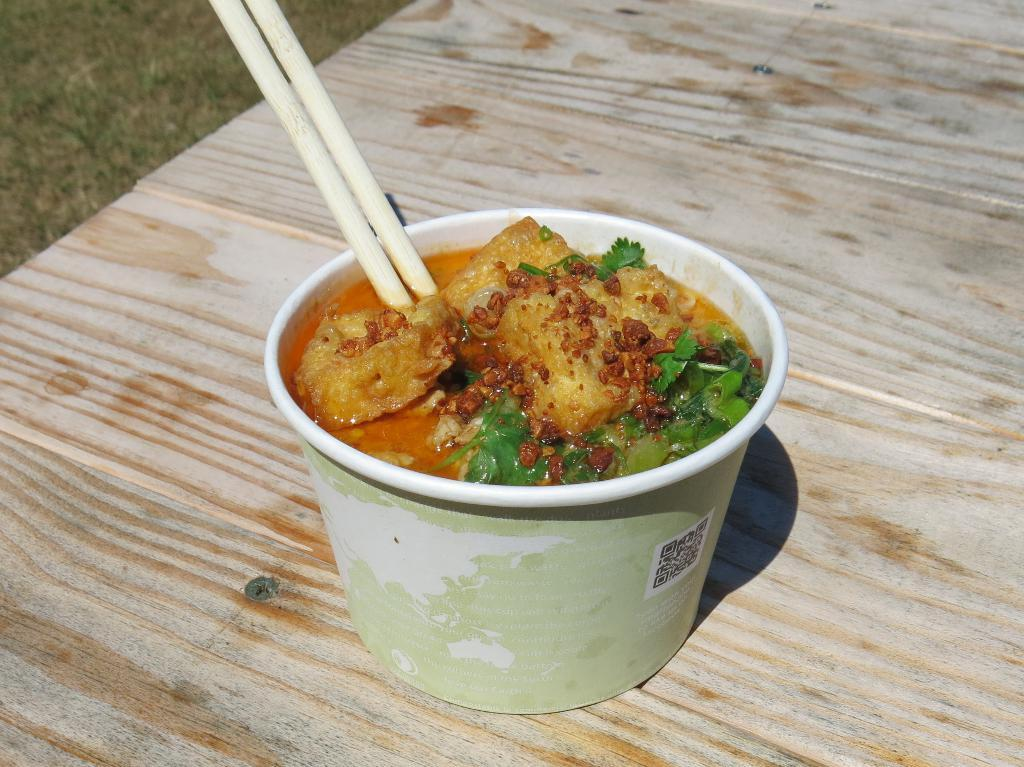What is in the bowl that is visible in the image? There is food in a bowl in the image. What utensil is present in the image? Chopsticks are visible in the image. What type of furniture is in the image? There is a table in the image. What type of blood is visible on the table in the image? There is no blood visible on the table in the image. 